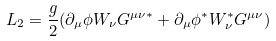Convert formula to latex. <formula><loc_0><loc_0><loc_500><loc_500>L _ { 2 } = \frac { g } { 2 } ( \partial _ { \mu } \phi W _ { \nu } G ^ { \mu \nu \ast } + \partial _ { \mu } \phi ^ { \ast } W _ { \nu } ^ { \ast } G ^ { \mu \nu } )</formula> 